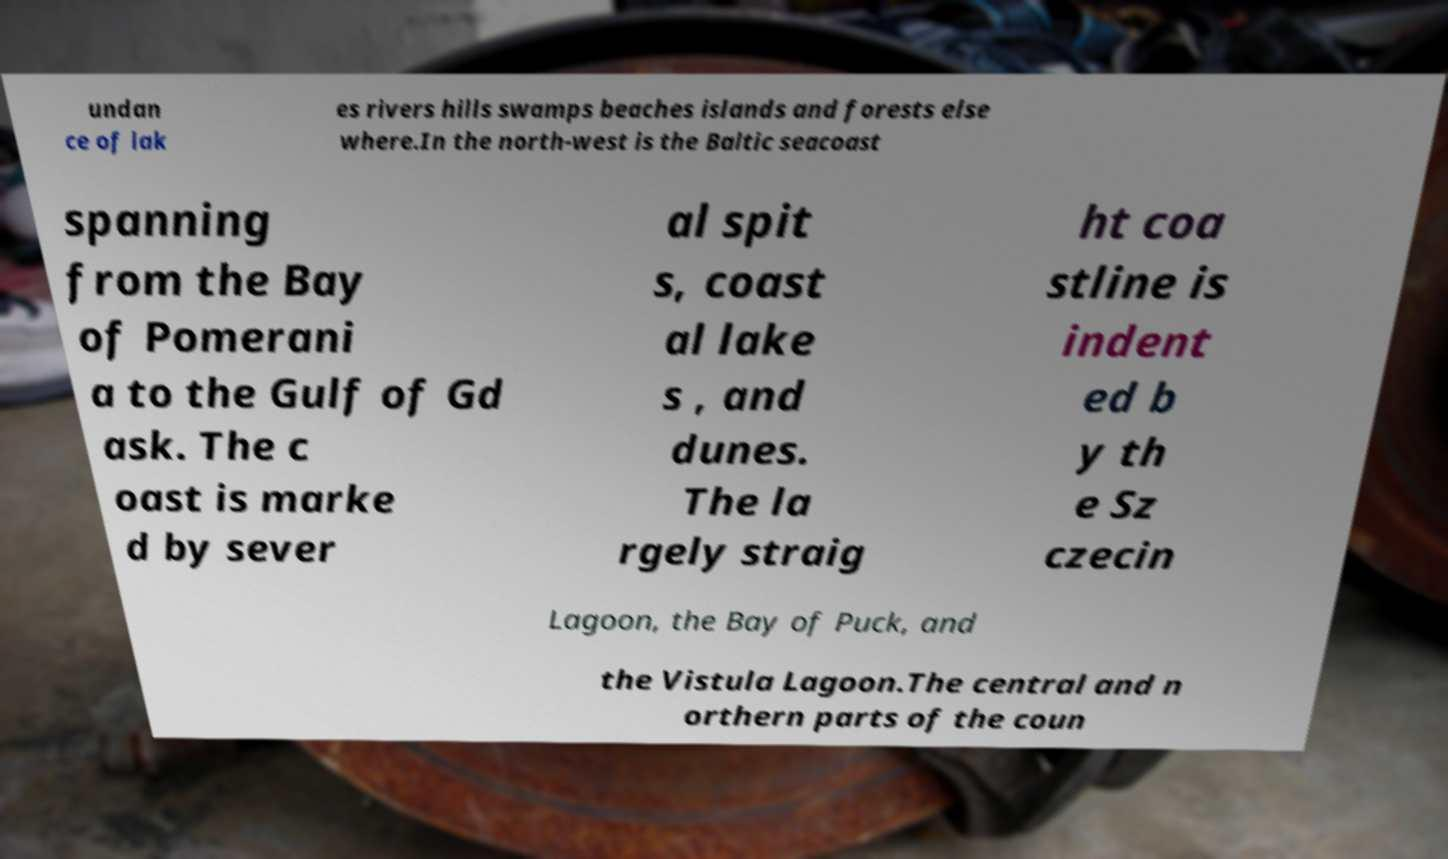Can you read and provide the text displayed in the image?This photo seems to have some interesting text. Can you extract and type it out for me? undan ce of lak es rivers hills swamps beaches islands and forests else where.In the north-west is the Baltic seacoast spanning from the Bay of Pomerani a to the Gulf of Gd ask. The c oast is marke d by sever al spit s, coast al lake s , and dunes. The la rgely straig ht coa stline is indent ed b y th e Sz czecin Lagoon, the Bay of Puck, and the Vistula Lagoon.The central and n orthern parts of the coun 